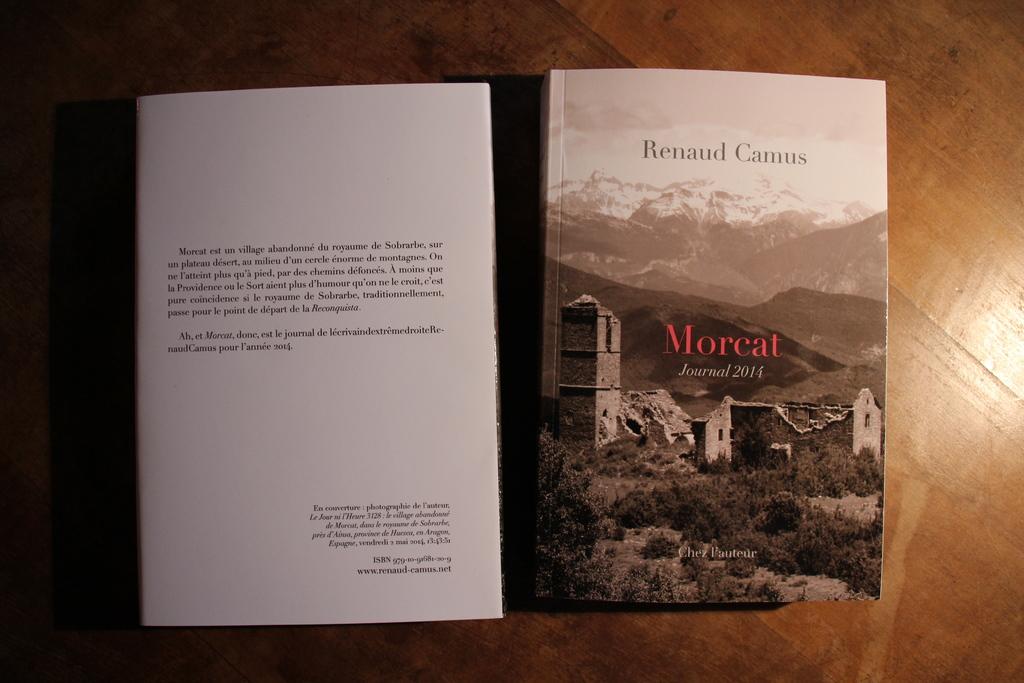Who is the author of the book?
Provide a succinct answer. Renaud camus. What is the year of this journal?
Offer a very short reply. 2014. 